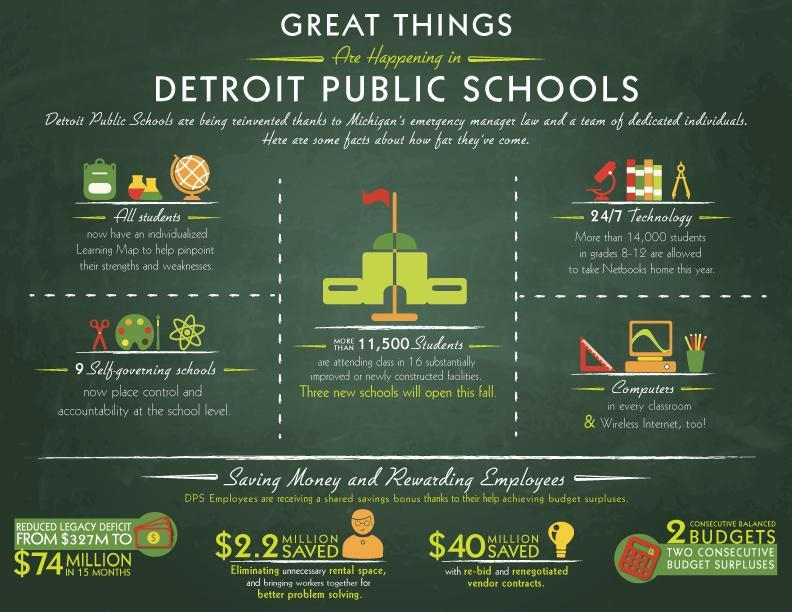What is the new feature introduced for students to attend classes from home?
Answer the question with a short phrase. Netbooks How many students are studying in recently built blocks? 11,500 students How much is the decrease in settlement debt amount within one and a half year in millions? 253 What is the new technology introduced to track the progress of children? Learning Map What are the new facilities available in study rooms of Detroit Public school? Computers, Wireless Internet 